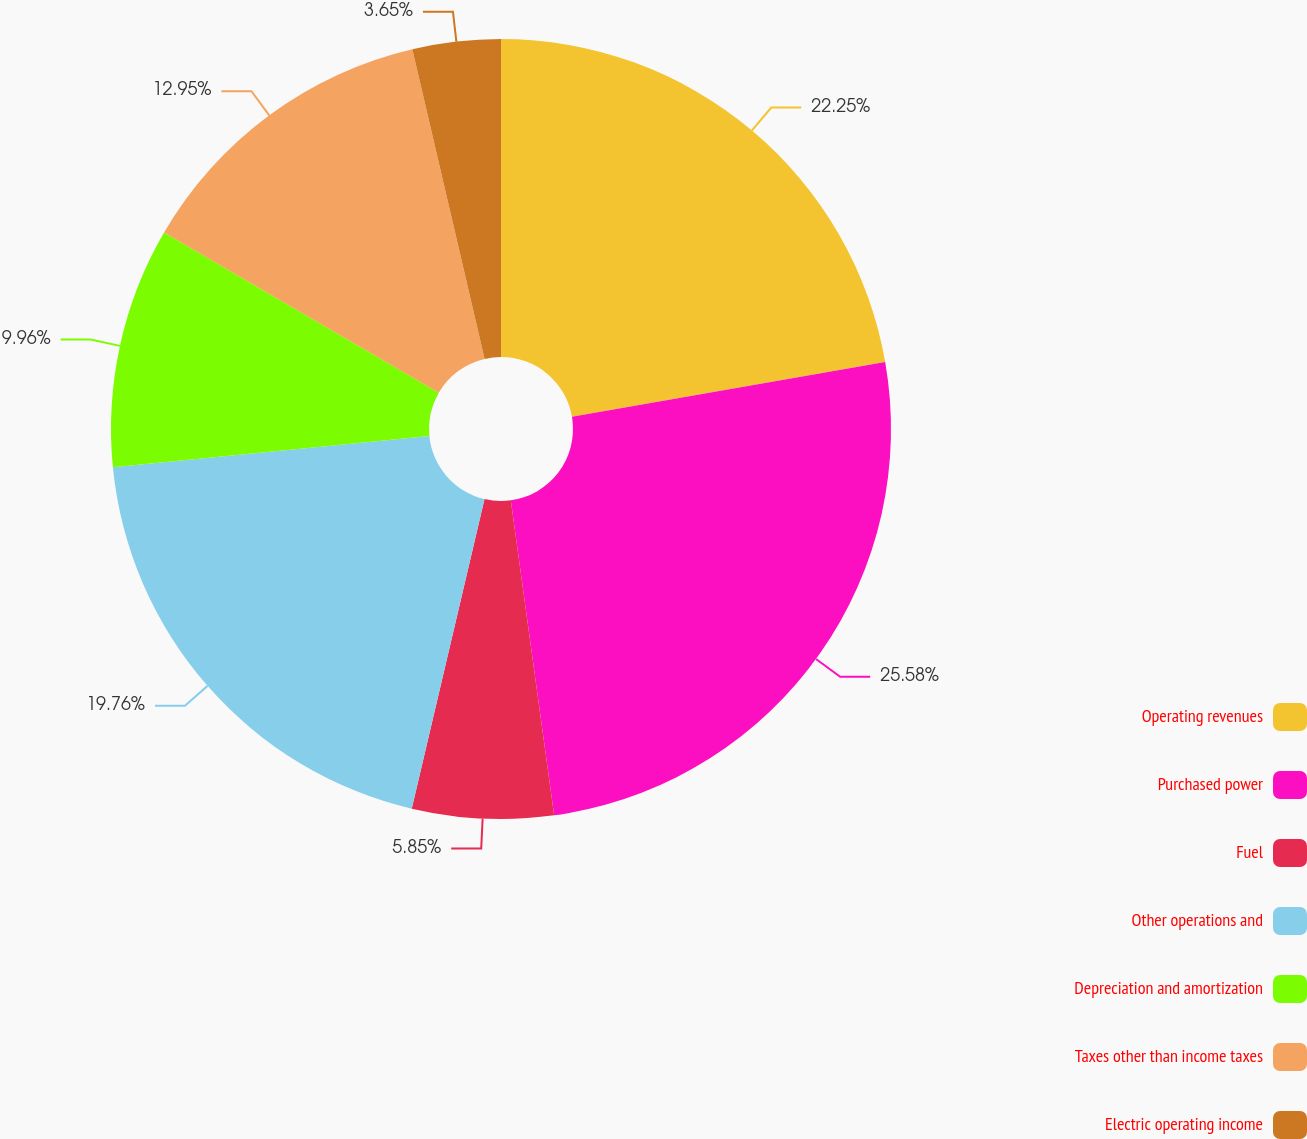Convert chart. <chart><loc_0><loc_0><loc_500><loc_500><pie_chart><fcel>Operating revenues<fcel>Purchased power<fcel>Fuel<fcel>Other operations and<fcel>Depreciation and amortization<fcel>Taxes other than income taxes<fcel>Electric operating income<nl><fcel>22.25%<fcel>25.57%<fcel>5.85%<fcel>19.76%<fcel>9.96%<fcel>12.95%<fcel>3.65%<nl></chart> 